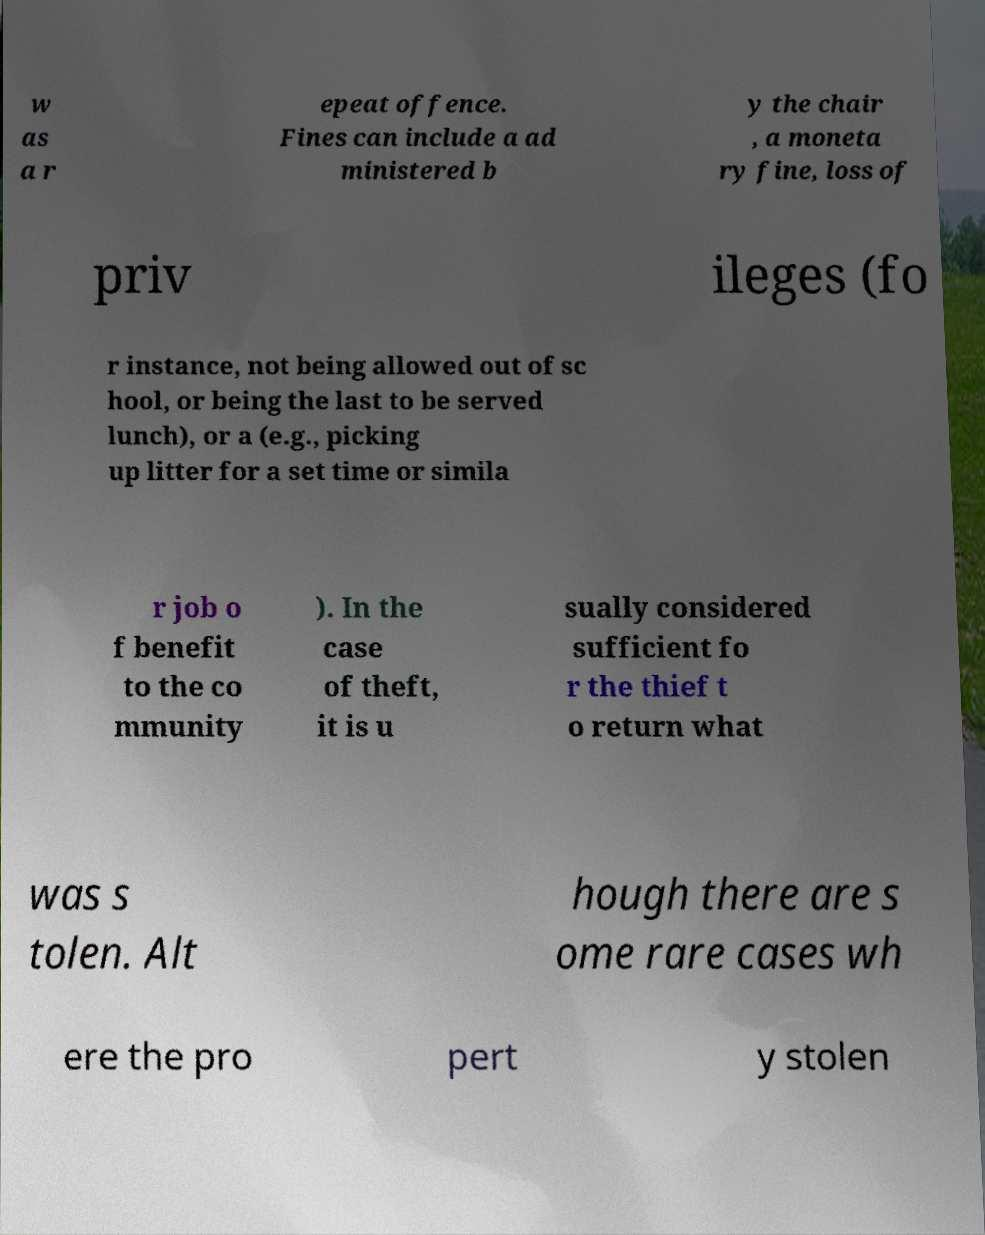Please read and relay the text visible in this image. What does it say? w as a r epeat offence. Fines can include a ad ministered b y the chair , a moneta ry fine, loss of priv ileges (fo r instance, not being allowed out of sc hool, or being the last to be served lunch), or a (e.g., picking up litter for a set time or simila r job o f benefit to the co mmunity ). In the case of theft, it is u sually considered sufficient fo r the thief t o return what was s tolen. Alt hough there are s ome rare cases wh ere the pro pert y stolen 